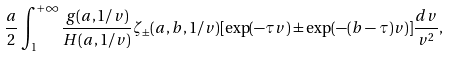<formula> <loc_0><loc_0><loc_500><loc_500>\frac { a } { 2 } \int _ { 1 } ^ { + \infty } \frac { g ( a , 1 / v ) } { H ( a , 1 / v ) } \zeta _ { \pm } ( a , b , 1 / v ) [ \exp ( - \tau v ) \pm \exp ( - ( b - \tau ) v ) ] \frac { d v } { v ^ { 2 } } ,</formula> 